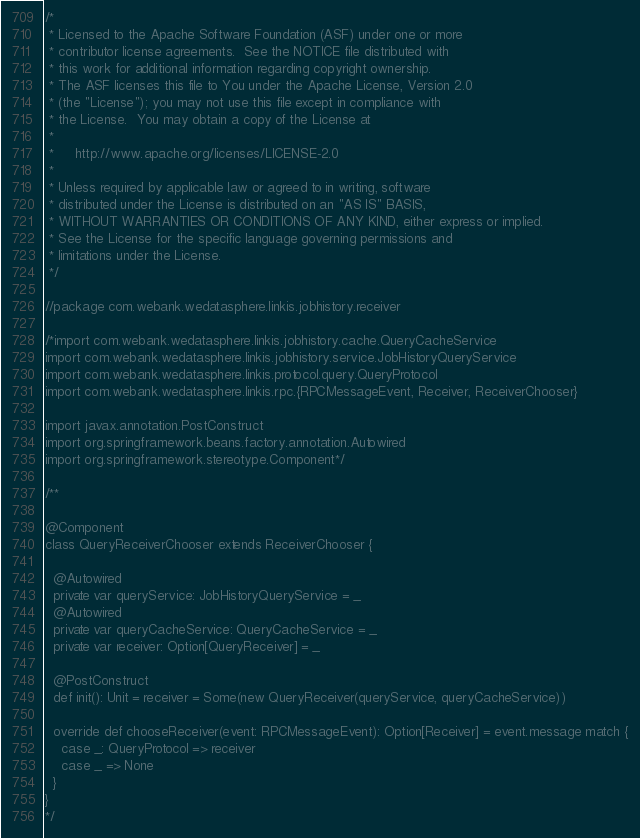<code> <loc_0><loc_0><loc_500><loc_500><_Scala_>/*
 * Licensed to the Apache Software Foundation (ASF) under one or more
 * contributor license agreements.  See the NOTICE file distributed with
 * this work for additional information regarding copyright ownership.
 * The ASF licenses this file to You under the Apache License, Version 2.0
 * (the "License"); you may not use this file except in compliance with
 * the License.  You may obtain a copy of the License at
 *
 *     http://www.apache.org/licenses/LICENSE-2.0
 *
 * Unless required by applicable law or agreed to in writing, software
 * distributed under the License is distributed on an "AS IS" BASIS,
 * WITHOUT WARRANTIES OR CONDITIONS OF ANY KIND, either express or implied.
 * See the License for the specific language governing permissions and
 * limitations under the License.
 */

//package com.webank.wedatasphere.linkis.jobhistory.receiver

/*import com.webank.wedatasphere.linkis.jobhistory.cache.QueryCacheService
import com.webank.wedatasphere.linkis.jobhistory.service.JobHistoryQueryService
import com.webank.wedatasphere.linkis.protocol.query.QueryProtocol
import com.webank.wedatasphere.linkis.rpc.{RPCMessageEvent, Receiver, ReceiverChooser}

import javax.annotation.PostConstruct
import org.springframework.beans.factory.annotation.Autowired
import org.springframework.stereotype.Component*/

/**

@Component
class QueryReceiverChooser extends ReceiverChooser {

  @Autowired
  private var queryService: JobHistoryQueryService = _
  @Autowired
  private var queryCacheService: QueryCacheService = _
  private var receiver: Option[QueryReceiver] = _

  @PostConstruct
  def init(): Unit = receiver = Some(new QueryReceiver(queryService, queryCacheService))

  override def chooseReceiver(event: RPCMessageEvent): Option[Receiver] = event.message match {
    case _: QueryProtocol => receiver
    case _ => None
  }
}
*/
</code> 